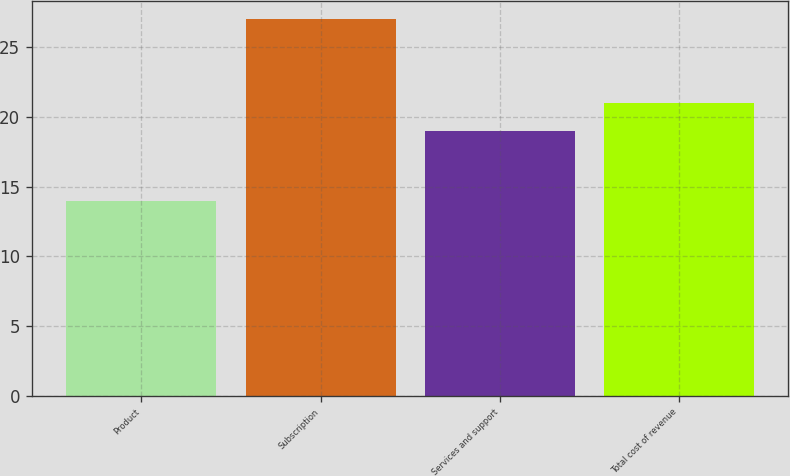Convert chart. <chart><loc_0><loc_0><loc_500><loc_500><bar_chart><fcel>Product<fcel>Subscription<fcel>Services and support<fcel>Total cost of revenue<nl><fcel>14<fcel>27<fcel>19<fcel>21<nl></chart> 